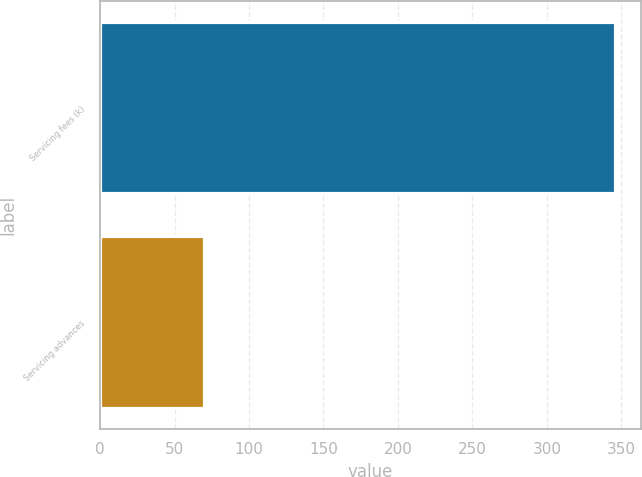Convert chart to OTSL. <chart><loc_0><loc_0><loc_500><loc_500><bar_chart><fcel>Servicing fees (k)<fcel>Servicing advances<nl><fcel>346<fcel>70<nl></chart> 